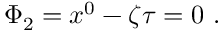<formula> <loc_0><loc_0><loc_500><loc_500>\Phi _ { 2 } = x ^ { 0 } - \zeta \tau = 0 .</formula> 